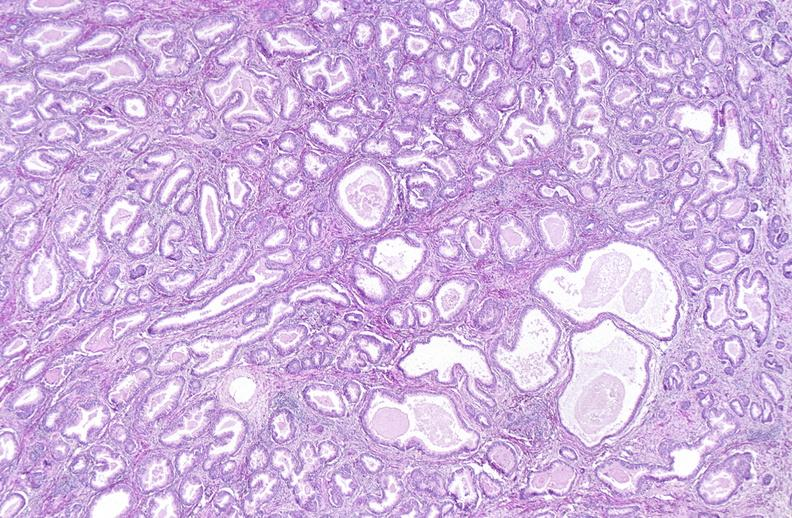does this image show prostate, benign prostatic hyperplasia?
Answer the question using a single word or phrase. Yes 